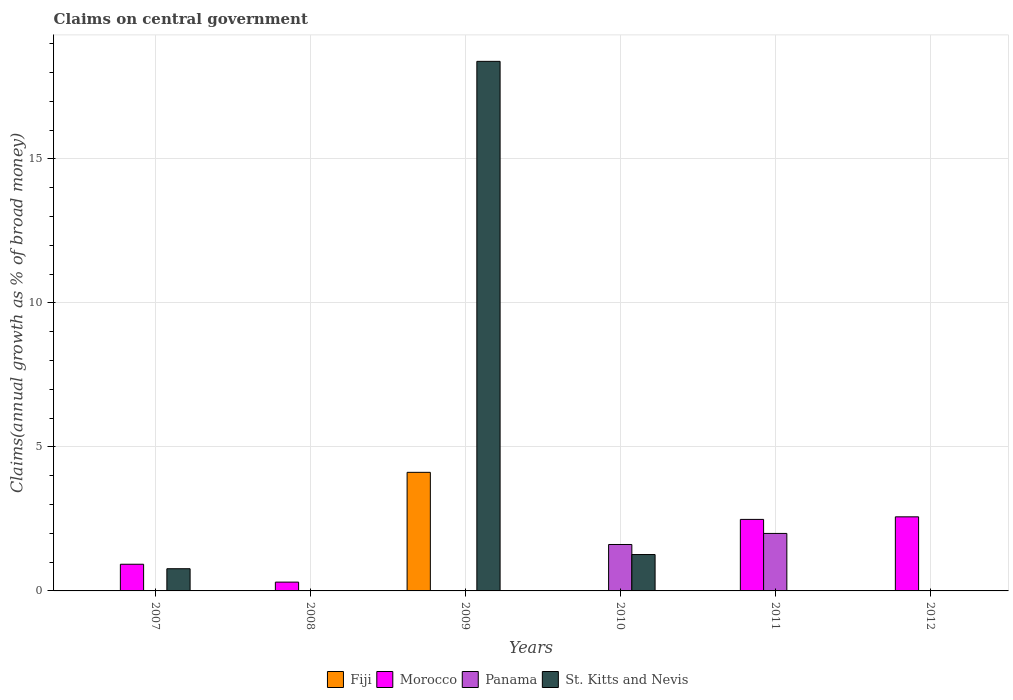How many different coloured bars are there?
Keep it short and to the point. 4. Are the number of bars per tick equal to the number of legend labels?
Ensure brevity in your answer.  No. How many bars are there on the 1st tick from the left?
Provide a short and direct response. 2. How many bars are there on the 4th tick from the right?
Your response must be concise. 2. What is the percentage of broad money claimed on centeral government in Panama in 2011?
Keep it short and to the point. 2. Across all years, what is the maximum percentage of broad money claimed on centeral government in Morocco?
Make the answer very short. 2.57. Across all years, what is the minimum percentage of broad money claimed on centeral government in Morocco?
Offer a terse response. 0. In which year was the percentage of broad money claimed on centeral government in Morocco maximum?
Offer a terse response. 2012. What is the total percentage of broad money claimed on centeral government in Fiji in the graph?
Give a very brief answer. 4.12. What is the difference between the percentage of broad money claimed on centeral government in Morocco in 2011 and that in 2012?
Give a very brief answer. -0.09. What is the difference between the percentage of broad money claimed on centeral government in St. Kitts and Nevis in 2009 and the percentage of broad money claimed on centeral government in Morocco in 2012?
Give a very brief answer. 15.81. What is the average percentage of broad money claimed on centeral government in Fiji per year?
Make the answer very short. 0.69. In how many years, is the percentage of broad money claimed on centeral government in Morocco greater than 1 %?
Give a very brief answer. 2. What is the ratio of the percentage of broad money claimed on centeral government in St. Kitts and Nevis in 2009 to that in 2010?
Your answer should be compact. 14.56. What is the difference between the highest and the second highest percentage of broad money claimed on centeral government in St. Kitts and Nevis?
Make the answer very short. 17.12. What is the difference between the highest and the lowest percentage of broad money claimed on centeral government in Morocco?
Offer a terse response. 2.57. How many bars are there?
Offer a terse response. 10. How many legend labels are there?
Provide a short and direct response. 4. What is the title of the graph?
Your answer should be compact. Claims on central government. What is the label or title of the Y-axis?
Give a very brief answer. Claims(annual growth as % of broad money). What is the Claims(annual growth as % of broad money) of Fiji in 2007?
Keep it short and to the point. 0. What is the Claims(annual growth as % of broad money) in Morocco in 2007?
Your response must be concise. 0.93. What is the Claims(annual growth as % of broad money) of St. Kitts and Nevis in 2007?
Provide a short and direct response. 0.77. What is the Claims(annual growth as % of broad money) of Morocco in 2008?
Offer a terse response. 0.31. What is the Claims(annual growth as % of broad money) of Panama in 2008?
Offer a terse response. 0. What is the Claims(annual growth as % of broad money) of St. Kitts and Nevis in 2008?
Your answer should be compact. 0. What is the Claims(annual growth as % of broad money) of Fiji in 2009?
Provide a succinct answer. 4.12. What is the Claims(annual growth as % of broad money) in Morocco in 2009?
Offer a very short reply. 0. What is the Claims(annual growth as % of broad money) of St. Kitts and Nevis in 2009?
Ensure brevity in your answer.  18.39. What is the Claims(annual growth as % of broad money) in Morocco in 2010?
Offer a terse response. 0. What is the Claims(annual growth as % of broad money) of Panama in 2010?
Provide a short and direct response. 1.61. What is the Claims(annual growth as % of broad money) of St. Kitts and Nevis in 2010?
Give a very brief answer. 1.26. What is the Claims(annual growth as % of broad money) of Fiji in 2011?
Your answer should be compact. 0. What is the Claims(annual growth as % of broad money) of Morocco in 2011?
Give a very brief answer. 2.48. What is the Claims(annual growth as % of broad money) in Panama in 2011?
Keep it short and to the point. 2. What is the Claims(annual growth as % of broad money) in Fiji in 2012?
Provide a short and direct response. 0. What is the Claims(annual growth as % of broad money) in Morocco in 2012?
Make the answer very short. 2.57. What is the Claims(annual growth as % of broad money) in Panama in 2012?
Your response must be concise. 0. Across all years, what is the maximum Claims(annual growth as % of broad money) in Fiji?
Your answer should be very brief. 4.12. Across all years, what is the maximum Claims(annual growth as % of broad money) in Morocco?
Provide a short and direct response. 2.57. Across all years, what is the maximum Claims(annual growth as % of broad money) of Panama?
Your response must be concise. 2. Across all years, what is the maximum Claims(annual growth as % of broad money) in St. Kitts and Nevis?
Give a very brief answer. 18.39. Across all years, what is the minimum Claims(annual growth as % of broad money) of Morocco?
Ensure brevity in your answer.  0. Across all years, what is the minimum Claims(annual growth as % of broad money) of Panama?
Offer a very short reply. 0. Across all years, what is the minimum Claims(annual growth as % of broad money) of St. Kitts and Nevis?
Keep it short and to the point. 0. What is the total Claims(annual growth as % of broad money) of Fiji in the graph?
Keep it short and to the point. 4.12. What is the total Claims(annual growth as % of broad money) of Morocco in the graph?
Keep it short and to the point. 6.29. What is the total Claims(annual growth as % of broad money) in Panama in the graph?
Offer a very short reply. 3.61. What is the total Claims(annual growth as % of broad money) of St. Kitts and Nevis in the graph?
Provide a succinct answer. 20.42. What is the difference between the Claims(annual growth as % of broad money) in Morocco in 2007 and that in 2008?
Offer a very short reply. 0.62. What is the difference between the Claims(annual growth as % of broad money) of St. Kitts and Nevis in 2007 and that in 2009?
Provide a succinct answer. -17.61. What is the difference between the Claims(annual growth as % of broad money) in St. Kitts and Nevis in 2007 and that in 2010?
Your answer should be compact. -0.49. What is the difference between the Claims(annual growth as % of broad money) of Morocco in 2007 and that in 2011?
Provide a short and direct response. -1.56. What is the difference between the Claims(annual growth as % of broad money) in Morocco in 2007 and that in 2012?
Offer a terse response. -1.65. What is the difference between the Claims(annual growth as % of broad money) of Morocco in 2008 and that in 2011?
Provide a short and direct response. -2.18. What is the difference between the Claims(annual growth as % of broad money) in Morocco in 2008 and that in 2012?
Your answer should be compact. -2.27. What is the difference between the Claims(annual growth as % of broad money) in St. Kitts and Nevis in 2009 and that in 2010?
Provide a short and direct response. 17.12. What is the difference between the Claims(annual growth as % of broad money) in Panama in 2010 and that in 2011?
Your response must be concise. -0.38. What is the difference between the Claims(annual growth as % of broad money) in Morocco in 2011 and that in 2012?
Your answer should be very brief. -0.09. What is the difference between the Claims(annual growth as % of broad money) in Morocco in 2007 and the Claims(annual growth as % of broad money) in St. Kitts and Nevis in 2009?
Your answer should be compact. -17.46. What is the difference between the Claims(annual growth as % of broad money) in Morocco in 2007 and the Claims(annual growth as % of broad money) in Panama in 2010?
Provide a succinct answer. -0.69. What is the difference between the Claims(annual growth as % of broad money) in Morocco in 2007 and the Claims(annual growth as % of broad money) in St. Kitts and Nevis in 2010?
Provide a short and direct response. -0.34. What is the difference between the Claims(annual growth as % of broad money) of Morocco in 2007 and the Claims(annual growth as % of broad money) of Panama in 2011?
Make the answer very short. -1.07. What is the difference between the Claims(annual growth as % of broad money) of Morocco in 2008 and the Claims(annual growth as % of broad money) of St. Kitts and Nevis in 2009?
Your answer should be very brief. -18.08. What is the difference between the Claims(annual growth as % of broad money) in Morocco in 2008 and the Claims(annual growth as % of broad money) in Panama in 2010?
Give a very brief answer. -1.31. What is the difference between the Claims(annual growth as % of broad money) of Morocco in 2008 and the Claims(annual growth as % of broad money) of St. Kitts and Nevis in 2010?
Make the answer very short. -0.96. What is the difference between the Claims(annual growth as % of broad money) in Morocco in 2008 and the Claims(annual growth as % of broad money) in Panama in 2011?
Offer a terse response. -1.69. What is the difference between the Claims(annual growth as % of broad money) of Fiji in 2009 and the Claims(annual growth as % of broad money) of Panama in 2010?
Offer a very short reply. 2.51. What is the difference between the Claims(annual growth as % of broad money) of Fiji in 2009 and the Claims(annual growth as % of broad money) of St. Kitts and Nevis in 2010?
Your response must be concise. 2.85. What is the difference between the Claims(annual growth as % of broad money) in Fiji in 2009 and the Claims(annual growth as % of broad money) in Morocco in 2011?
Your answer should be very brief. 1.63. What is the difference between the Claims(annual growth as % of broad money) in Fiji in 2009 and the Claims(annual growth as % of broad money) in Panama in 2011?
Ensure brevity in your answer.  2.12. What is the difference between the Claims(annual growth as % of broad money) in Fiji in 2009 and the Claims(annual growth as % of broad money) in Morocco in 2012?
Offer a very short reply. 1.54. What is the average Claims(annual growth as % of broad money) of Fiji per year?
Make the answer very short. 0.69. What is the average Claims(annual growth as % of broad money) of Morocco per year?
Your answer should be compact. 1.05. What is the average Claims(annual growth as % of broad money) of Panama per year?
Offer a terse response. 0.6. What is the average Claims(annual growth as % of broad money) in St. Kitts and Nevis per year?
Your answer should be compact. 3.4. In the year 2007, what is the difference between the Claims(annual growth as % of broad money) in Morocco and Claims(annual growth as % of broad money) in St. Kitts and Nevis?
Provide a succinct answer. 0.16. In the year 2009, what is the difference between the Claims(annual growth as % of broad money) in Fiji and Claims(annual growth as % of broad money) in St. Kitts and Nevis?
Make the answer very short. -14.27. In the year 2010, what is the difference between the Claims(annual growth as % of broad money) in Panama and Claims(annual growth as % of broad money) in St. Kitts and Nevis?
Provide a succinct answer. 0.35. In the year 2011, what is the difference between the Claims(annual growth as % of broad money) of Morocco and Claims(annual growth as % of broad money) of Panama?
Keep it short and to the point. 0.49. What is the ratio of the Claims(annual growth as % of broad money) of Morocco in 2007 to that in 2008?
Give a very brief answer. 3.03. What is the ratio of the Claims(annual growth as % of broad money) in St. Kitts and Nevis in 2007 to that in 2009?
Your response must be concise. 0.04. What is the ratio of the Claims(annual growth as % of broad money) in St. Kitts and Nevis in 2007 to that in 2010?
Make the answer very short. 0.61. What is the ratio of the Claims(annual growth as % of broad money) of Morocco in 2007 to that in 2011?
Ensure brevity in your answer.  0.37. What is the ratio of the Claims(annual growth as % of broad money) of Morocco in 2007 to that in 2012?
Offer a very short reply. 0.36. What is the ratio of the Claims(annual growth as % of broad money) in Morocco in 2008 to that in 2011?
Provide a short and direct response. 0.12. What is the ratio of the Claims(annual growth as % of broad money) in Morocco in 2008 to that in 2012?
Offer a terse response. 0.12. What is the ratio of the Claims(annual growth as % of broad money) of St. Kitts and Nevis in 2009 to that in 2010?
Offer a terse response. 14.56. What is the ratio of the Claims(annual growth as % of broad money) of Panama in 2010 to that in 2011?
Your answer should be very brief. 0.81. What is the ratio of the Claims(annual growth as % of broad money) of Morocco in 2011 to that in 2012?
Your response must be concise. 0.97. What is the difference between the highest and the second highest Claims(annual growth as % of broad money) of Morocco?
Give a very brief answer. 0.09. What is the difference between the highest and the second highest Claims(annual growth as % of broad money) of St. Kitts and Nevis?
Your answer should be compact. 17.12. What is the difference between the highest and the lowest Claims(annual growth as % of broad money) of Fiji?
Provide a succinct answer. 4.12. What is the difference between the highest and the lowest Claims(annual growth as % of broad money) in Morocco?
Offer a very short reply. 2.57. What is the difference between the highest and the lowest Claims(annual growth as % of broad money) of Panama?
Give a very brief answer. 2. What is the difference between the highest and the lowest Claims(annual growth as % of broad money) of St. Kitts and Nevis?
Give a very brief answer. 18.39. 